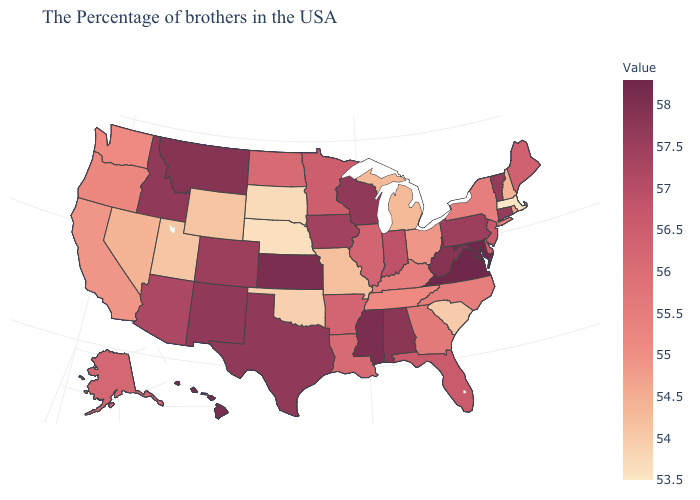Does the map have missing data?
Short answer required. No. Does Pennsylvania have the lowest value in the USA?
Give a very brief answer. No. Does Missouri have a higher value than South Dakota?
Quick response, please. Yes. Does Nevada have the highest value in the USA?
Write a very short answer. No. Among the states that border Illinois , which have the highest value?
Short answer required. Wisconsin. Is the legend a continuous bar?
Be succinct. Yes. Does the map have missing data?
Concise answer only. No. Is the legend a continuous bar?
Write a very short answer. Yes. 